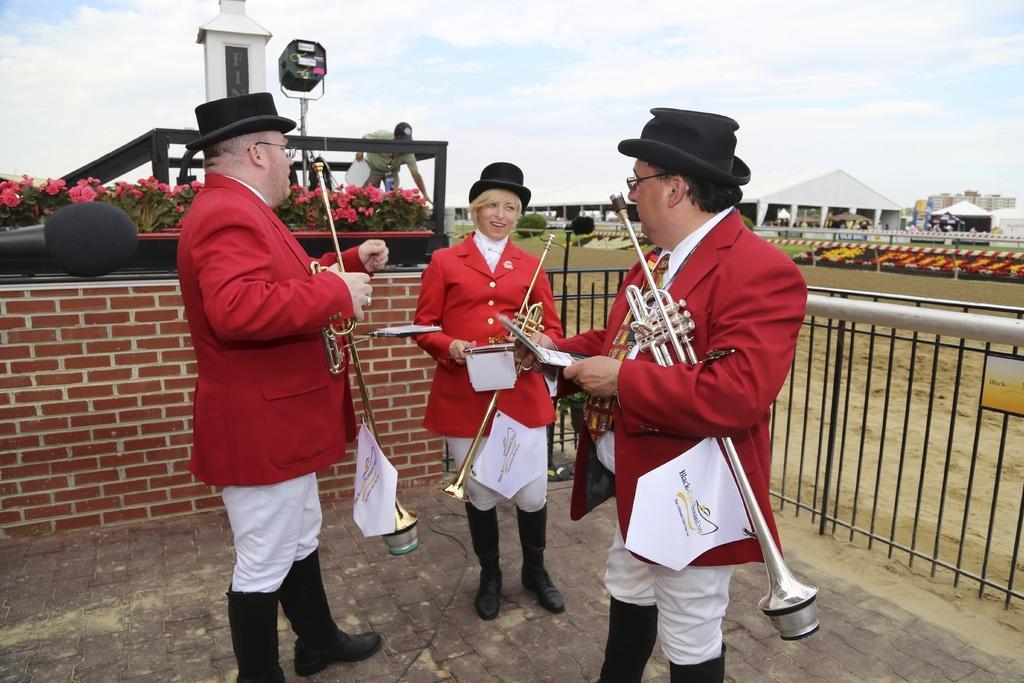Could you give a brief overview of what you see in this image? These three people are holding musical instruments. Here we can see plants with flowers and a person. Backside of this people there is a fence. Sky is cloudy. Far there are buildings and sheds.   